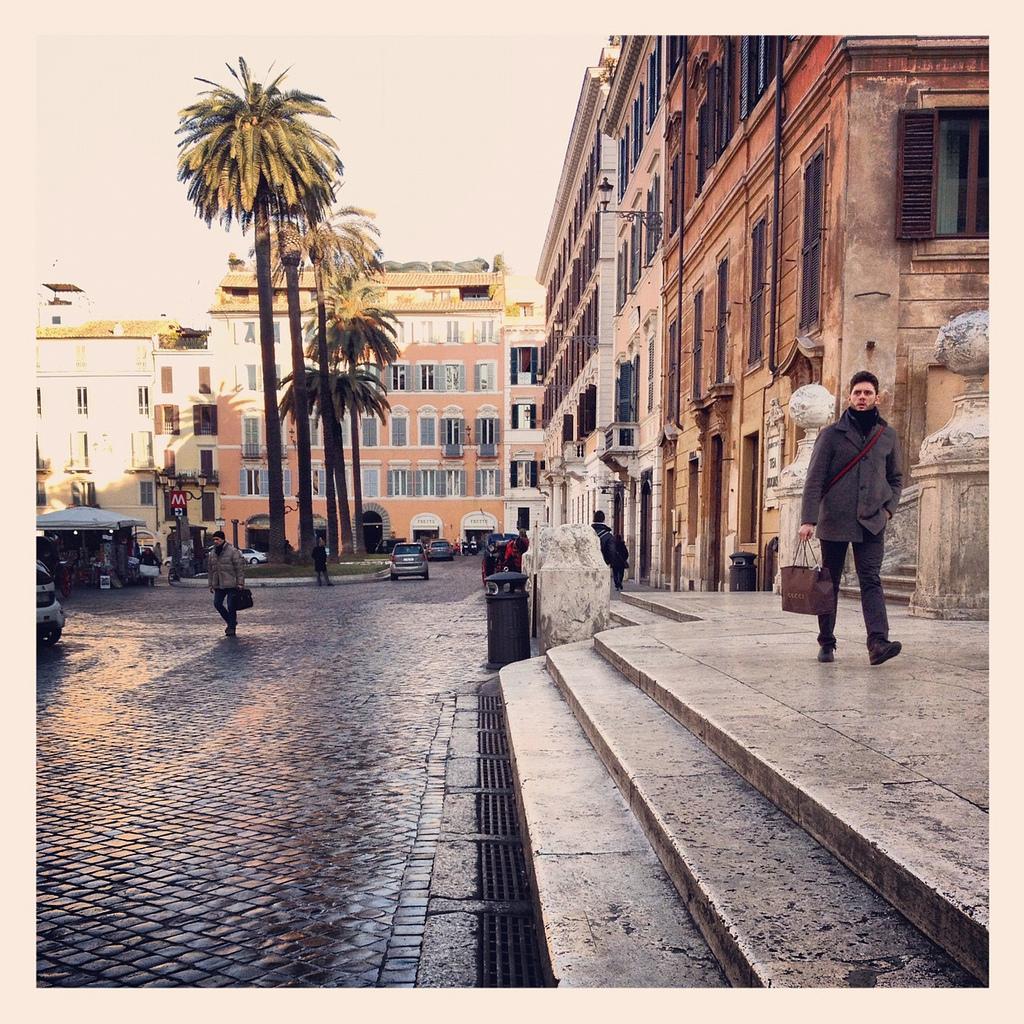Describe this image in one or two sentences. This image is taken outdoors. At the bottom of the image there is a floor and there are few stairs. At the top of the image there is the sky. In the background there are a few buildings with walls, windows and roofs. In the middle of the image two cars are moving on the road. On the left side of the image a car is parked on the floor and there is a tent. Two people are walking on the floor. On the right side of the image a man is walking on the floor. 